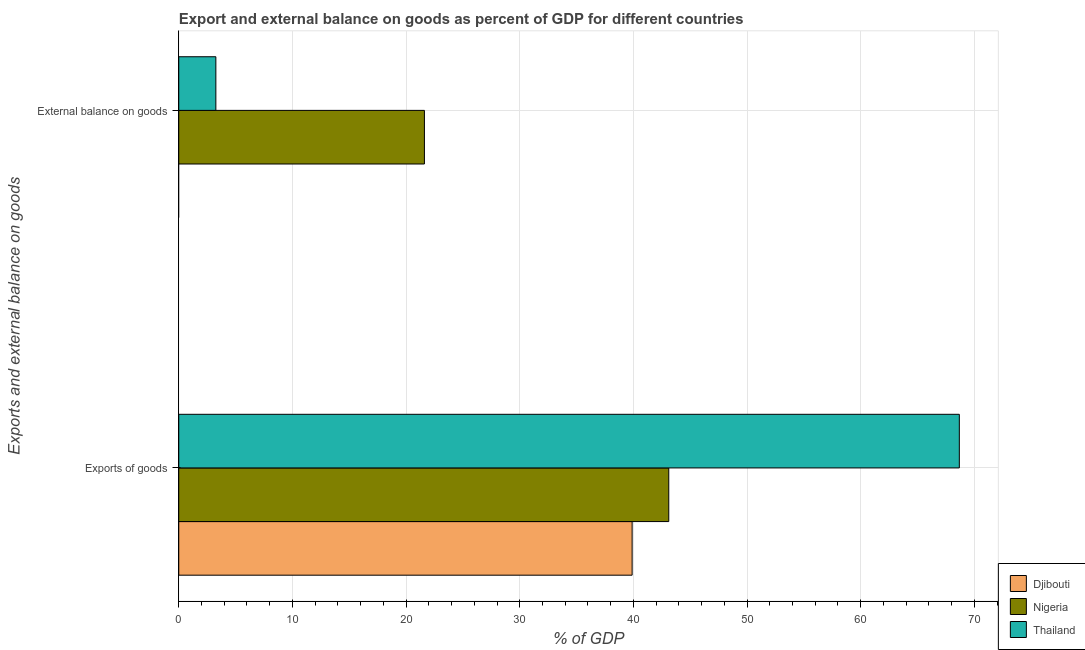Are the number of bars on each tick of the Y-axis equal?
Ensure brevity in your answer.  No. How many bars are there on the 1st tick from the top?
Your response must be concise. 2. How many bars are there on the 2nd tick from the bottom?
Provide a succinct answer. 2. What is the label of the 2nd group of bars from the top?
Your answer should be compact. Exports of goods. What is the external balance on goods as percentage of gdp in Nigeria?
Your answer should be compact. 21.61. Across all countries, what is the maximum export of goods as percentage of gdp?
Your answer should be very brief. 68.68. In which country was the external balance on goods as percentage of gdp maximum?
Keep it short and to the point. Nigeria. What is the total export of goods as percentage of gdp in the graph?
Ensure brevity in your answer.  151.67. What is the difference between the export of goods as percentage of gdp in Nigeria and that in Djibouti?
Make the answer very short. 3.22. What is the difference between the external balance on goods as percentage of gdp in Thailand and the export of goods as percentage of gdp in Djibouti?
Give a very brief answer. -36.62. What is the average external balance on goods as percentage of gdp per country?
Make the answer very short. 8.29. What is the difference between the export of goods as percentage of gdp and external balance on goods as percentage of gdp in Nigeria?
Make the answer very short. 21.5. In how many countries, is the export of goods as percentage of gdp greater than 8 %?
Give a very brief answer. 3. What is the ratio of the export of goods as percentage of gdp in Nigeria to that in Thailand?
Give a very brief answer. 0.63. In how many countries, is the export of goods as percentage of gdp greater than the average export of goods as percentage of gdp taken over all countries?
Give a very brief answer. 1. How many bars are there?
Your response must be concise. 5. What is the difference between two consecutive major ticks on the X-axis?
Offer a very short reply. 10. Are the values on the major ticks of X-axis written in scientific E-notation?
Provide a short and direct response. No. Where does the legend appear in the graph?
Your answer should be very brief. Bottom right. How many legend labels are there?
Ensure brevity in your answer.  3. How are the legend labels stacked?
Make the answer very short. Vertical. What is the title of the graph?
Provide a short and direct response. Export and external balance on goods as percent of GDP for different countries. Does "Maldives" appear as one of the legend labels in the graph?
Provide a succinct answer. No. What is the label or title of the X-axis?
Make the answer very short. % of GDP. What is the label or title of the Y-axis?
Offer a very short reply. Exports and external balance on goods. What is the % of GDP in Djibouti in Exports of goods?
Offer a terse response. 39.89. What is the % of GDP of Nigeria in Exports of goods?
Give a very brief answer. 43.11. What is the % of GDP in Thailand in Exports of goods?
Make the answer very short. 68.68. What is the % of GDP of Nigeria in External balance on goods?
Provide a succinct answer. 21.61. What is the % of GDP of Thailand in External balance on goods?
Give a very brief answer. 3.26. Across all Exports and external balance on goods, what is the maximum % of GDP of Djibouti?
Your answer should be compact. 39.89. Across all Exports and external balance on goods, what is the maximum % of GDP of Nigeria?
Ensure brevity in your answer.  43.11. Across all Exports and external balance on goods, what is the maximum % of GDP in Thailand?
Offer a terse response. 68.68. Across all Exports and external balance on goods, what is the minimum % of GDP of Djibouti?
Offer a terse response. 0. Across all Exports and external balance on goods, what is the minimum % of GDP in Nigeria?
Offer a terse response. 21.61. Across all Exports and external balance on goods, what is the minimum % of GDP in Thailand?
Your answer should be very brief. 3.26. What is the total % of GDP of Djibouti in the graph?
Your answer should be compact. 39.89. What is the total % of GDP in Nigeria in the graph?
Your answer should be compact. 64.72. What is the total % of GDP in Thailand in the graph?
Provide a short and direct response. 71.94. What is the difference between the % of GDP in Nigeria in Exports of goods and that in External balance on goods?
Your answer should be compact. 21.5. What is the difference between the % of GDP of Thailand in Exports of goods and that in External balance on goods?
Provide a succinct answer. 65.41. What is the difference between the % of GDP in Djibouti in Exports of goods and the % of GDP in Nigeria in External balance on goods?
Make the answer very short. 18.27. What is the difference between the % of GDP in Djibouti in Exports of goods and the % of GDP in Thailand in External balance on goods?
Ensure brevity in your answer.  36.62. What is the difference between the % of GDP of Nigeria in Exports of goods and the % of GDP of Thailand in External balance on goods?
Ensure brevity in your answer.  39.85. What is the average % of GDP of Djibouti per Exports and external balance on goods?
Your answer should be compact. 19.94. What is the average % of GDP in Nigeria per Exports and external balance on goods?
Keep it short and to the point. 32.36. What is the average % of GDP in Thailand per Exports and external balance on goods?
Your answer should be very brief. 35.97. What is the difference between the % of GDP of Djibouti and % of GDP of Nigeria in Exports of goods?
Provide a short and direct response. -3.22. What is the difference between the % of GDP in Djibouti and % of GDP in Thailand in Exports of goods?
Provide a short and direct response. -28.79. What is the difference between the % of GDP in Nigeria and % of GDP in Thailand in Exports of goods?
Your response must be concise. -25.56. What is the difference between the % of GDP of Nigeria and % of GDP of Thailand in External balance on goods?
Ensure brevity in your answer.  18.35. What is the ratio of the % of GDP in Nigeria in Exports of goods to that in External balance on goods?
Your response must be concise. 1.99. What is the ratio of the % of GDP of Thailand in Exports of goods to that in External balance on goods?
Give a very brief answer. 21.04. What is the difference between the highest and the second highest % of GDP of Nigeria?
Keep it short and to the point. 21.5. What is the difference between the highest and the second highest % of GDP in Thailand?
Offer a terse response. 65.41. What is the difference between the highest and the lowest % of GDP in Djibouti?
Give a very brief answer. 39.89. What is the difference between the highest and the lowest % of GDP of Nigeria?
Provide a succinct answer. 21.5. What is the difference between the highest and the lowest % of GDP of Thailand?
Make the answer very short. 65.41. 